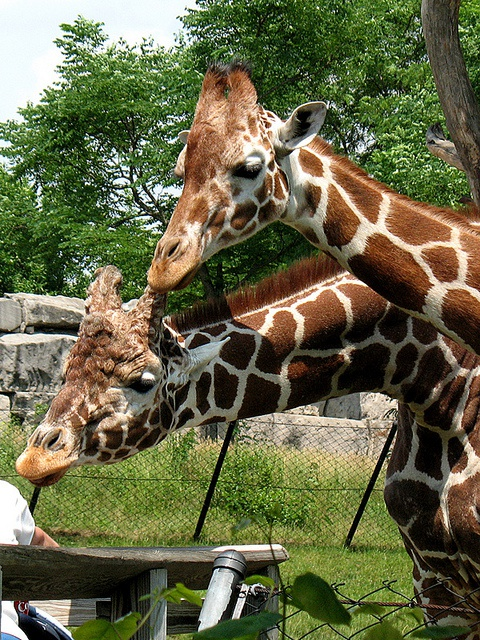Describe the objects in this image and their specific colors. I can see giraffe in white, black, gray, and maroon tones, giraffe in white, black, brown, maroon, and ivory tones, and people in white, darkgray, gray, and tan tones in this image. 